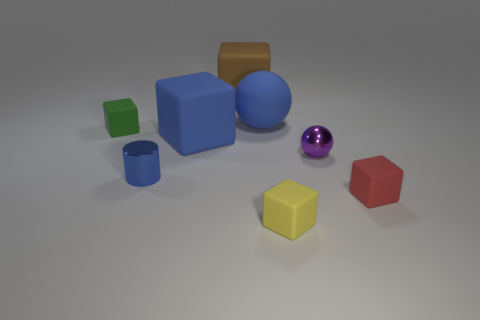Are there fewer cylinders in front of the tiny metallic cylinder than small purple matte blocks?
Provide a short and direct response. No. Is the red object made of the same material as the cylinder?
Provide a short and direct response. No. There is a yellow matte object that is the same shape as the tiny red rubber object; what is its size?
Your response must be concise. Small. What number of objects are matte objects that are in front of the green cube or big matte things that are in front of the small green rubber cube?
Your response must be concise. 3. Are there fewer blue balls than large red things?
Your response must be concise. No. There is a cylinder; is it the same size as the object that is in front of the small red matte block?
Your answer should be very brief. Yes. What number of rubber objects are either large cyan things or tiny cylinders?
Your response must be concise. 0. Is the number of tiny metallic cylinders greater than the number of tiny blue matte blocks?
Offer a very short reply. Yes. The rubber sphere that is the same color as the small shiny cylinder is what size?
Keep it short and to the point. Large. There is a blue object on the left side of the big rubber block that is in front of the green block; what is its shape?
Give a very brief answer. Cylinder. 